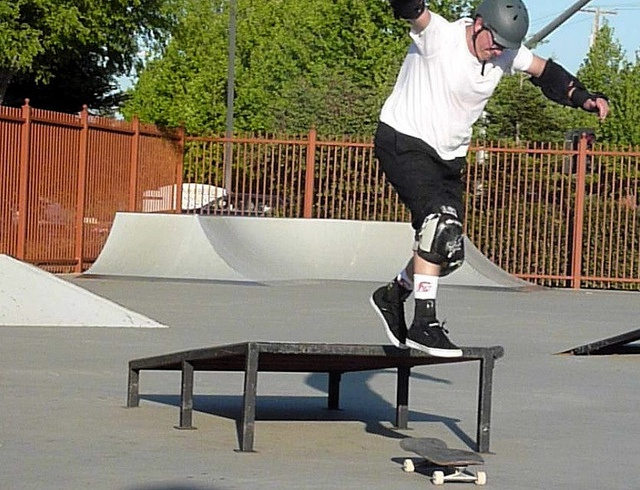Describe the objects in this image and their specific colors. I can see people in black, white, gray, and darkgray tones and skateboard in black, gray, ivory, and darkgray tones in this image. 